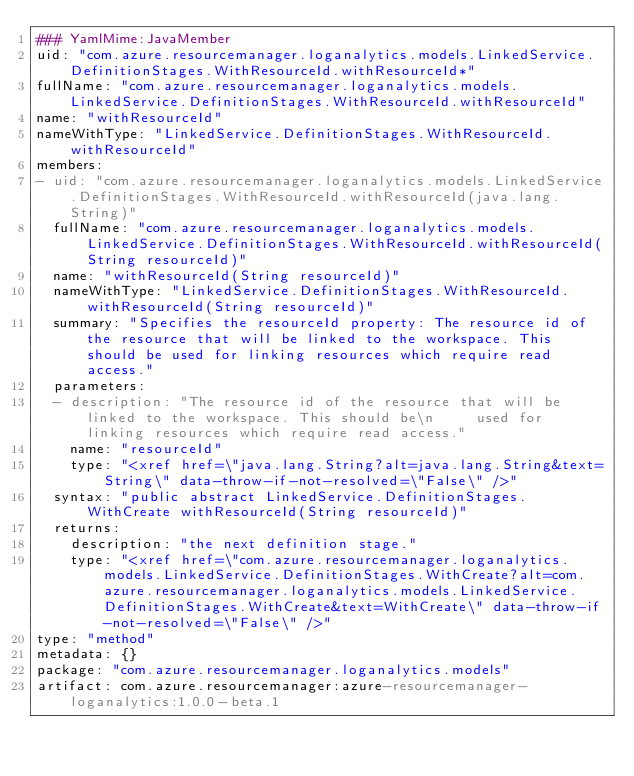Convert code to text. <code><loc_0><loc_0><loc_500><loc_500><_YAML_>### YamlMime:JavaMember
uid: "com.azure.resourcemanager.loganalytics.models.LinkedService.DefinitionStages.WithResourceId.withResourceId*"
fullName: "com.azure.resourcemanager.loganalytics.models.LinkedService.DefinitionStages.WithResourceId.withResourceId"
name: "withResourceId"
nameWithType: "LinkedService.DefinitionStages.WithResourceId.withResourceId"
members:
- uid: "com.azure.resourcemanager.loganalytics.models.LinkedService.DefinitionStages.WithResourceId.withResourceId(java.lang.String)"
  fullName: "com.azure.resourcemanager.loganalytics.models.LinkedService.DefinitionStages.WithResourceId.withResourceId(String resourceId)"
  name: "withResourceId(String resourceId)"
  nameWithType: "LinkedService.DefinitionStages.WithResourceId.withResourceId(String resourceId)"
  summary: "Specifies the resourceId property: The resource id of the resource that will be linked to the workspace. This should be used for linking resources which require read access."
  parameters:
  - description: "The resource id of the resource that will be linked to the workspace. This should be\n     used for linking resources which require read access."
    name: "resourceId"
    type: "<xref href=\"java.lang.String?alt=java.lang.String&text=String\" data-throw-if-not-resolved=\"False\" />"
  syntax: "public abstract LinkedService.DefinitionStages.WithCreate withResourceId(String resourceId)"
  returns:
    description: "the next definition stage."
    type: "<xref href=\"com.azure.resourcemanager.loganalytics.models.LinkedService.DefinitionStages.WithCreate?alt=com.azure.resourcemanager.loganalytics.models.LinkedService.DefinitionStages.WithCreate&text=WithCreate\" data-throw-if-not-resolved=\"False\" />"
type: "method"
metadata: {}
package: "com.azure.resourcemanager.loganalytics.models"
artifact: com.azure.resourcemanager:azure-resourcemanager-loganalytics:1.0.0-beta.1
</code> 